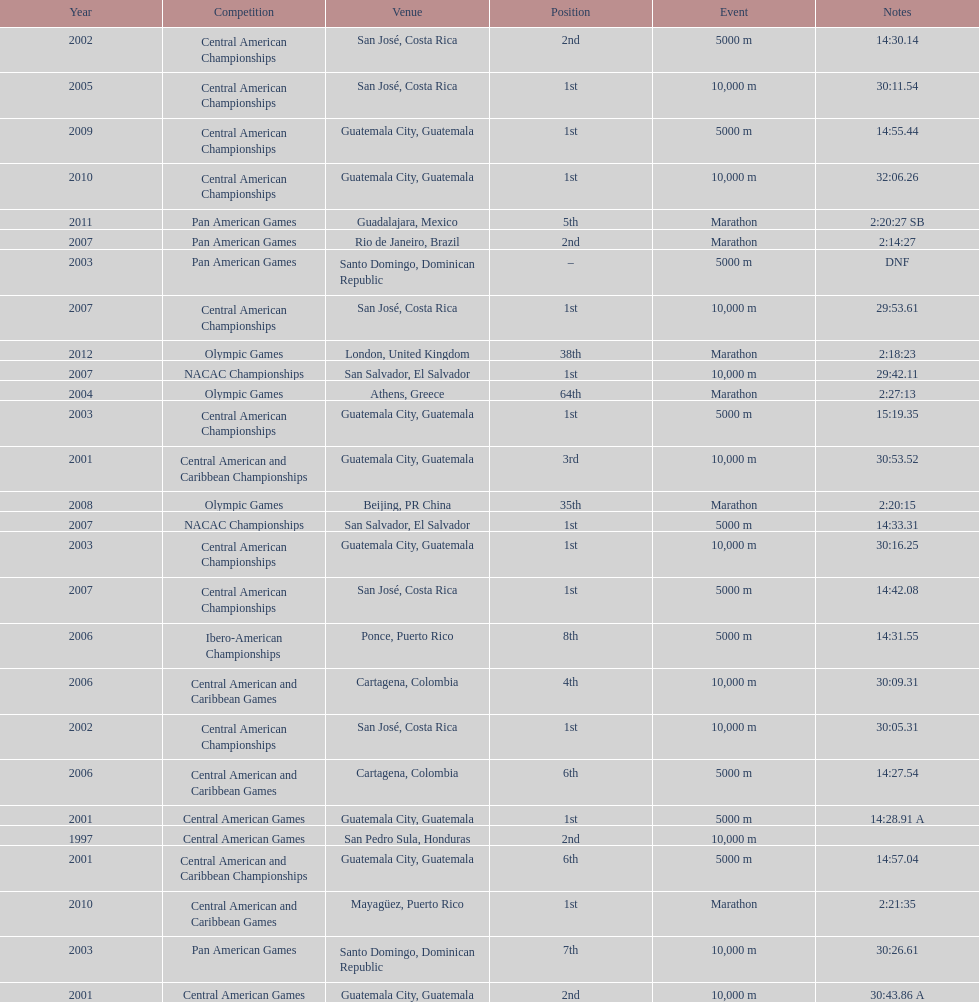Where was the only 64th position held? Athens, Greece. 